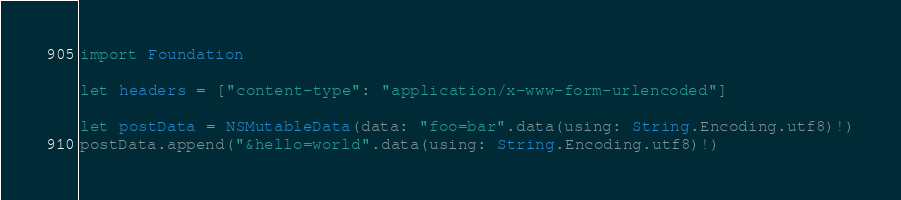<code> <loc_0><loc_0><loc_500><loc_500><_Swift_>import Foundation

let headers = ["content-type": "application/x-www-form-urlencoded"]

let postData = NSMutableData(data: "foo=bar".data(using: String.Encoding.utf8)!)
postData.append("&hello=world".data(using: String.Encoding.utf8)!)
</code> 